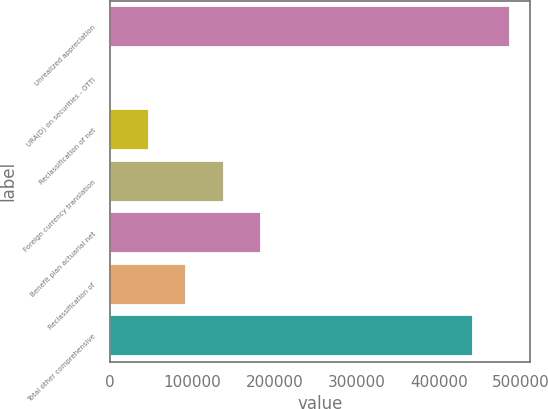Convert chart to OTSL. <chart><loc_0><loc_0><loc_500><loc_500><bar_chart><fcel>Unrealized appreciation<fcel>URA(D) on securities - OTTI<fcel>Reclassification of net<fcel>Foreign currency translation<fcel>Benefit plan actuarial net<fcel>Reclassification of<fcel>Total other comprehensive<nl><fcel>486851<fcel>1579<fcel>47140.3<fcel>138263<fcel>183824<fcel>92701.6<fcel>441290<nl></chart> 